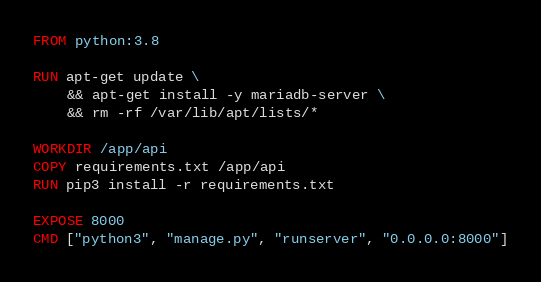Convert code to text. <code><loc_0><loc_0><loc_500><loc_500><_Dockerfile_>FROM python:3.8

RUN apt-get update \
    && apt-get install -y mariadb-server \
    && rm -rf /var/lib/apt/lists/*

WORKDIR /app/api
COPY requirements.txt /app/api
RUN pip3 install -r requirements.txt

EXPOSE 8000
CMD ["python3", "manage.py", "runserver", "0.0.0.0:8000"]</code> 